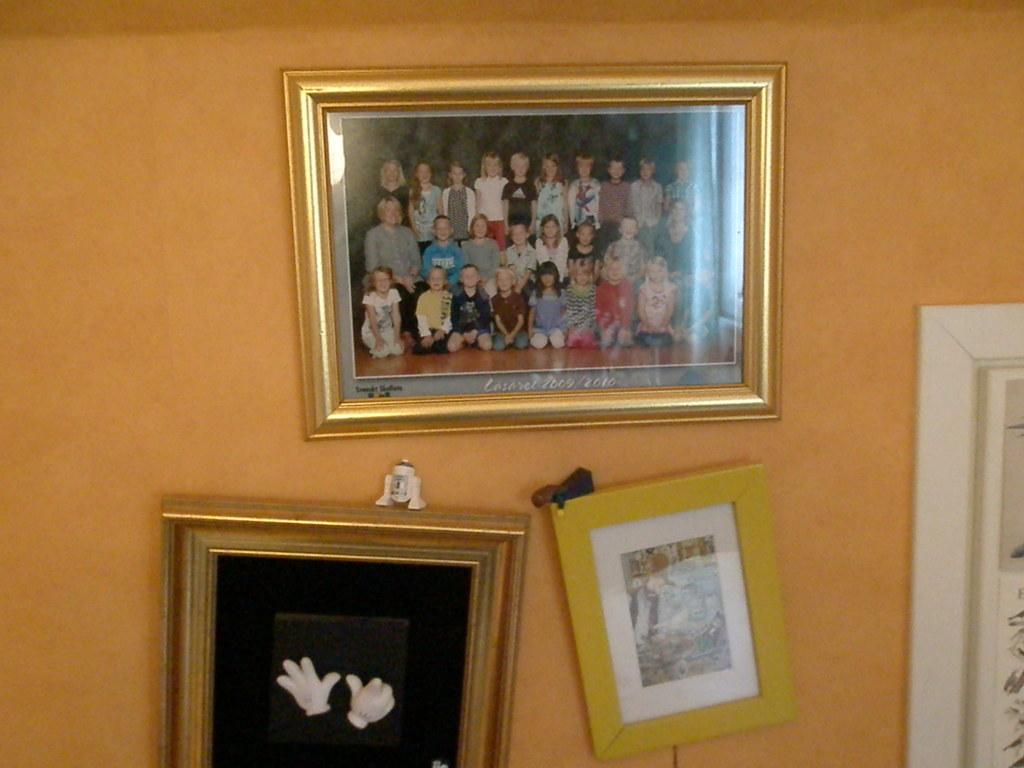<image>
Create a compact narrative representing the image presented. Picture framed on a wall from the class of 2009/2010. 